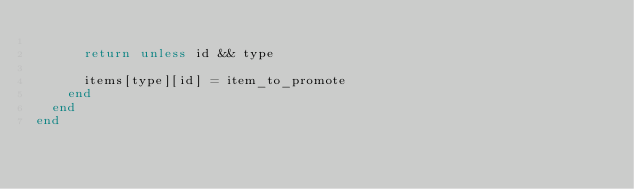<code> <loc_0><loc_0><loc_500><loc_500><_Ruby_>
      return unless id && type

      items[type][id] = item_to_promote
    end
  end
end
</code> 